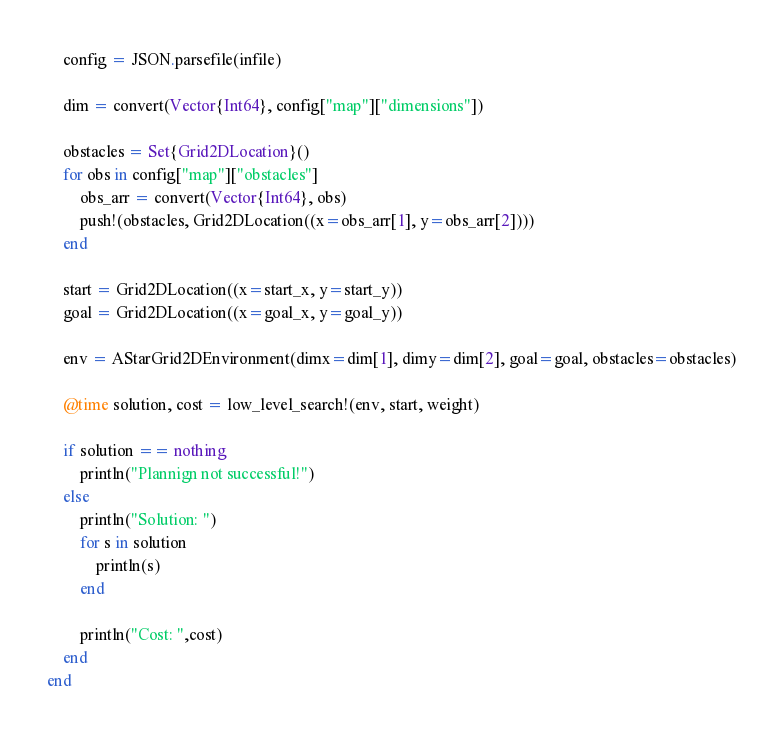<code> <loc_0><loc_0><loc_500><loc_500><_Julia_>    config = JSON.parsefile(infile)

    dim = convert(Vector{Int64}, config["map"]["dimensions"])

    obstacles = Set{Grid2DLocation}()
    for obs in config["map"]["obstacles"]
        obs_arr = convert(Vector{Int64}, obs)
        push!(obstacles, Grid2DLocation((x=obs_arr[1], y=obs_arr[2])))
    end

    start = Grid2DLocation((x=start_x, y=start_y))
    goal = Grid2DLocation((x=goal_x, y=goal_y))

    env = AStarGrid2DEnvironment(dimx=dim[1], dimy=dim[2], goal=goal, obstacles=obstacles)

    @time solution, cost = low_level_search!(env, start, weight)

    if solution == nothing
        println("Plannign not successful!")
    else
        println("Solution: ")
        for s in solution
            println(s)
        end

        println("Cost: ",cost)
    end
end
</code> 